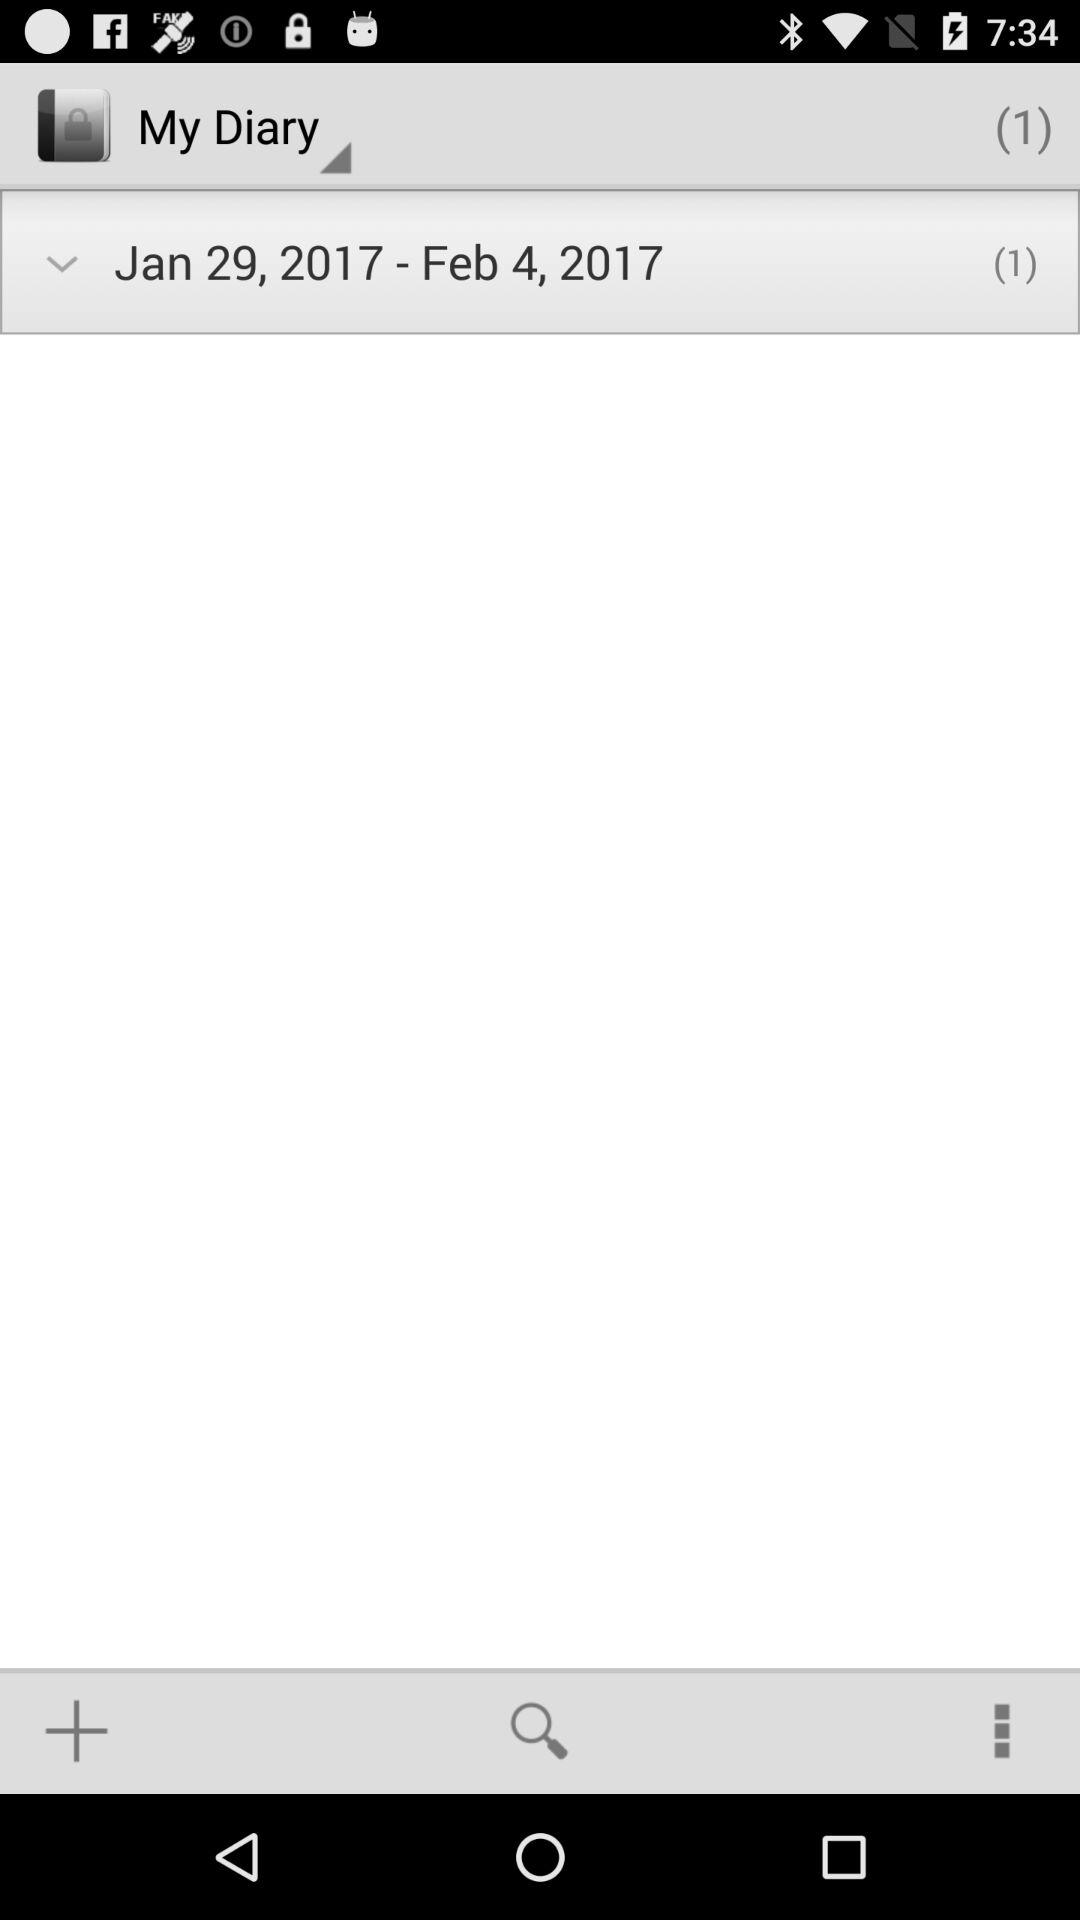What are the dates mentioned in my diary? The dates are January 29, 2017 to February 4, 2017. 